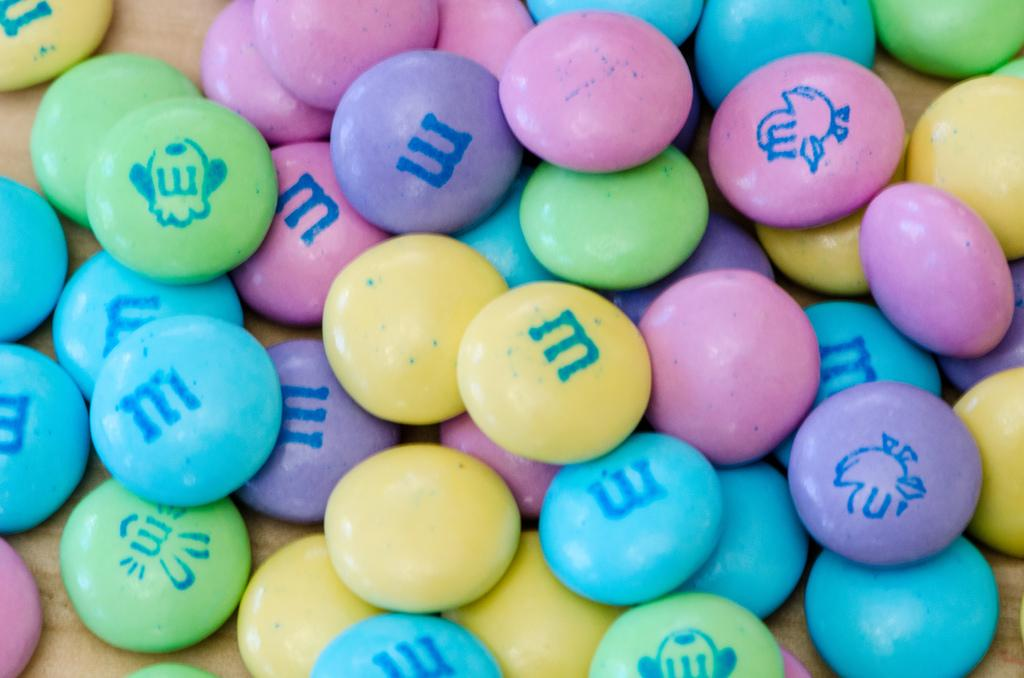What objects are present in the image? There are gems in the image. What is unique about these gems? The gems have something written on them. How can the gems be differentiated from one another? The gems are in different colors. What type of food can be seen in the image? There is no food present in the image; it features gems. How many frogs can be seen interacting with the gems in the image? There are no frogs present in the image. 